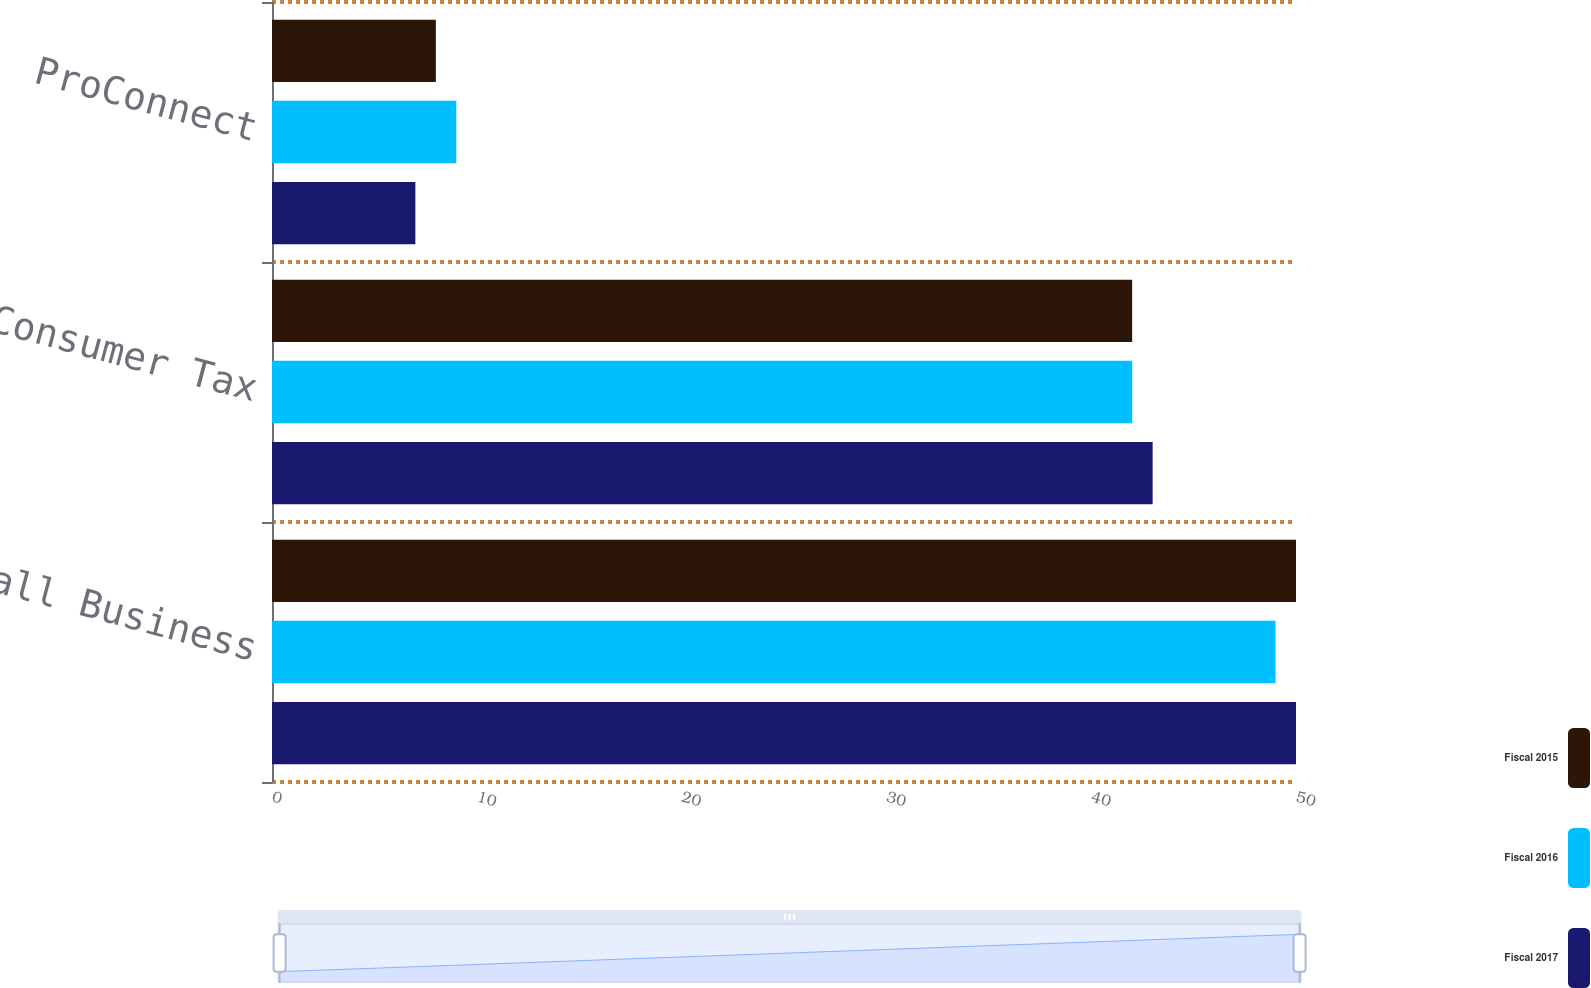Convert chart to OTSL. <chart><loc_0><loc_0><loc_500><loc_500><stacked_bar_chart><ecel><fcel>Small Business<fcel>Consumer Tax<fcel>ProConnect<nl><fcel>Fiscal 2015<fcel>50<fcel>42<fcel>8<nl><fcel>Fiscal 2016<fcel>49<fcel>42<fcel>9<nl><fcel>Fiscal 2017<fcel>50<fcel>43<fcel>7<nl></chart> 